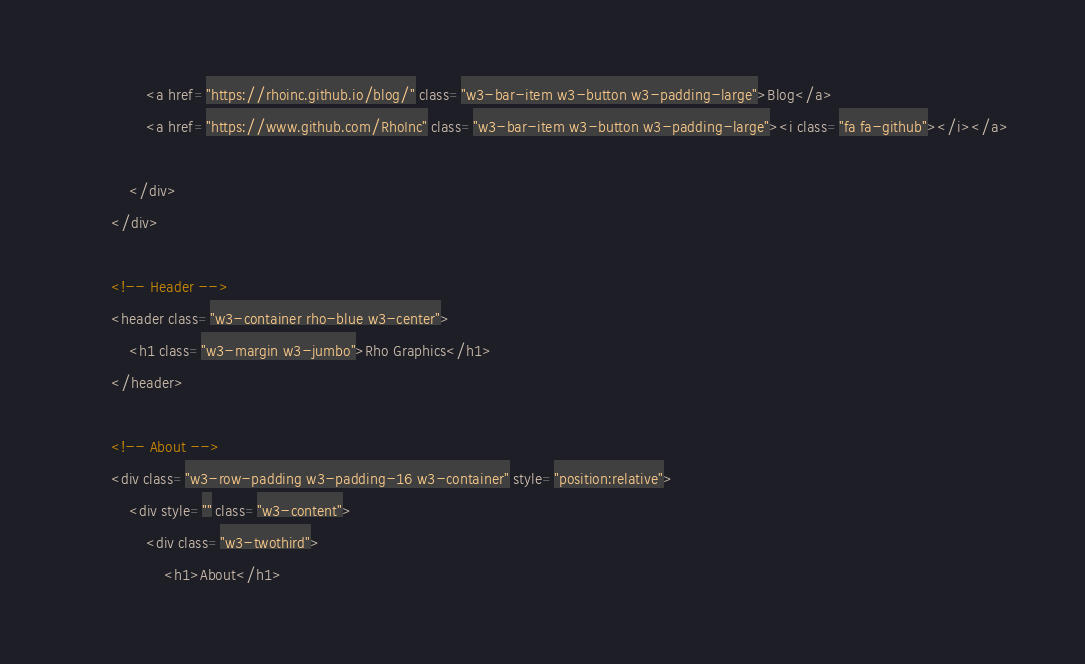<code> <loc_0><loc_0><loc_500><loc_500><_HTML_>                <a href="https://rhoinc.github.io/blog/" class="w3-bar-item w3-button w3-padding-large">Blog</a>
                <a href="https://www.github.com/RhoInc" class="w3-bar-item w3-button w3-padding-large"><i class="fa fa-github"></i></a>

            </div>
        </div>

        <!-- Header -->
        <header class="w3-container rho-blue w3-center">
            <h1 class="w3-margin w3-jumbo">Rho Graphics</h1>
        </header>

        <!-- About -->
        <div class="w3-row-padding w3-padding-16 w3-container" style="position:relative">
            <div style="" class="w3-content">
                <div class="w3-twothird">
                    <h1>About</h1></code> 